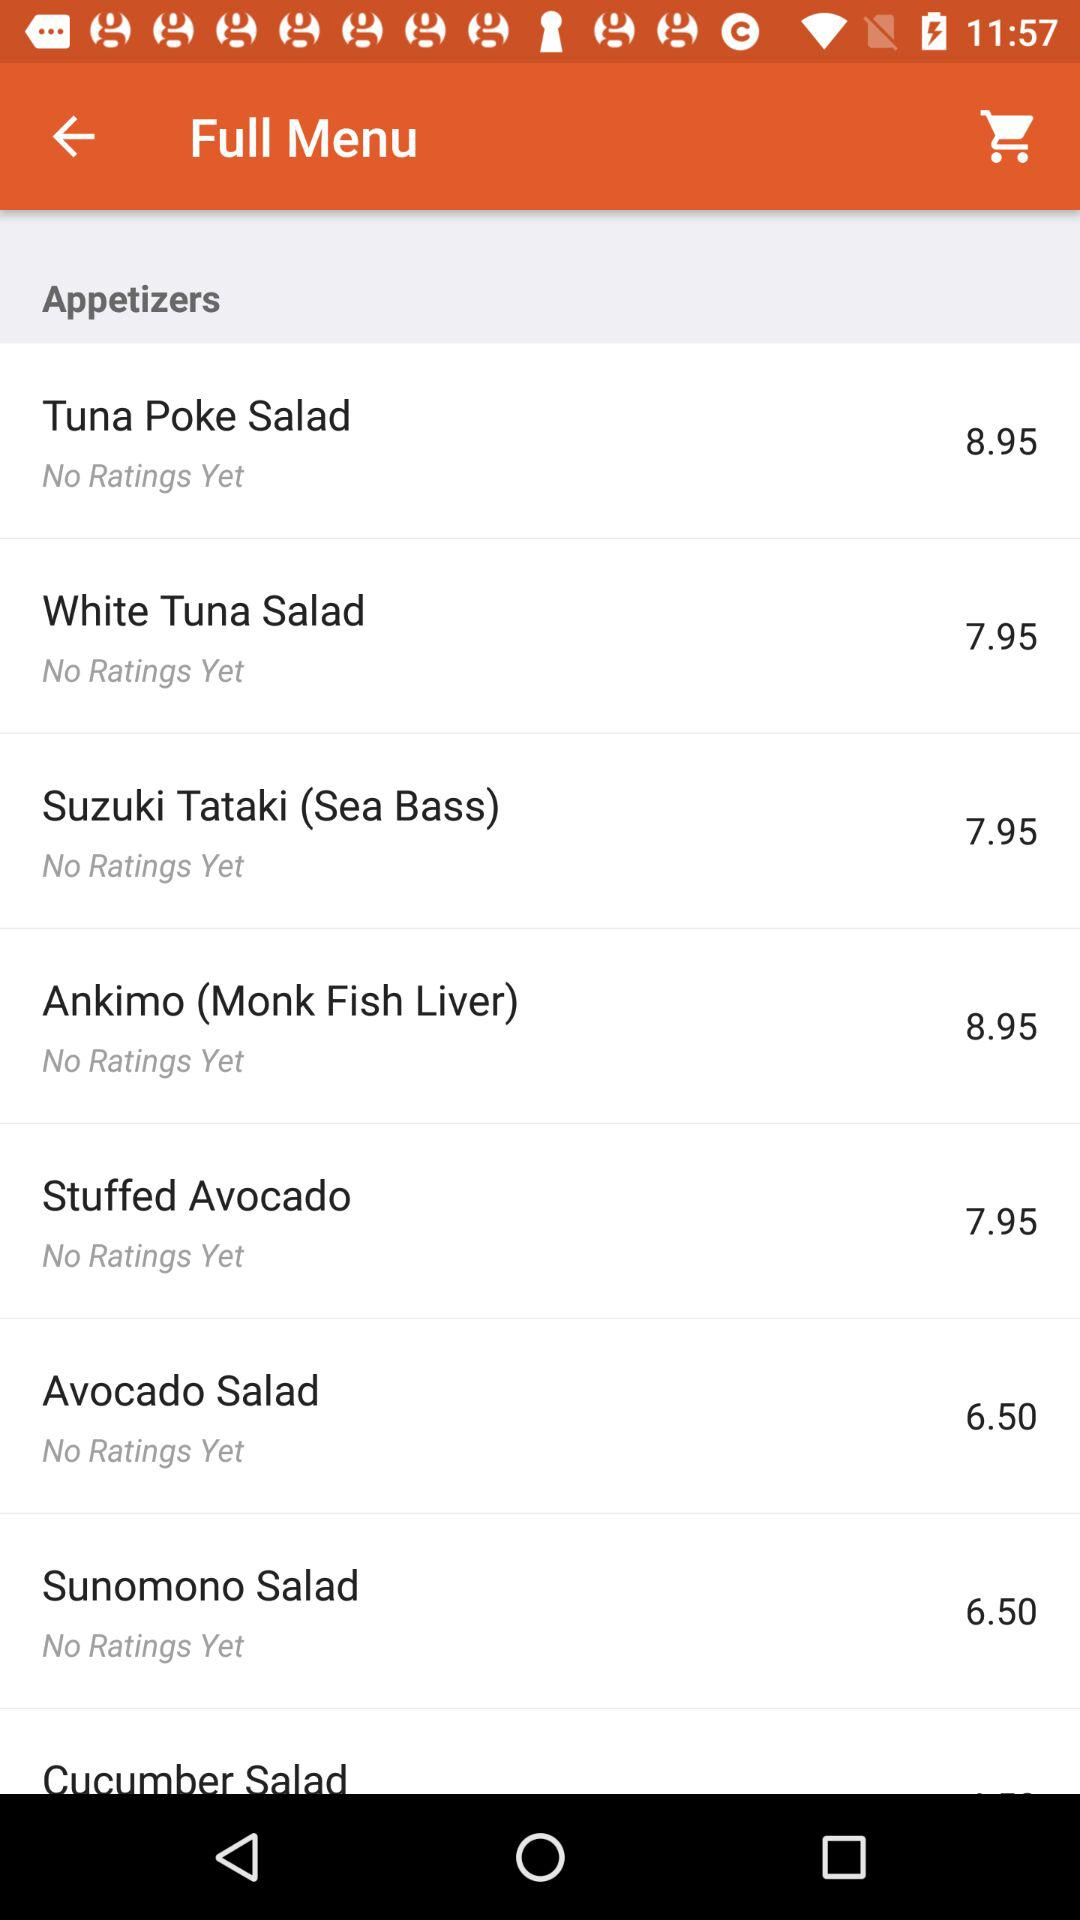What are the ratings for white tuna salad? There are no ratings for white tuna salad. 